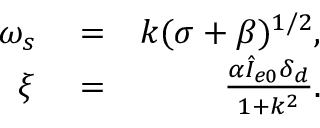<formula> <loc_0><loc_0><loc_500><loc_500>\begin{array} { r l r } { \omega _ { s } } & = } & { k ( \sigma + \beta ) ^ { 1 / 2 } , } \\ { \xi } & = } & { \frac { \alpha \hat { I } _ { e 0 } \delta _ { d } } { 1 + k ^ { 2 } } . } \end{array}</formula> 